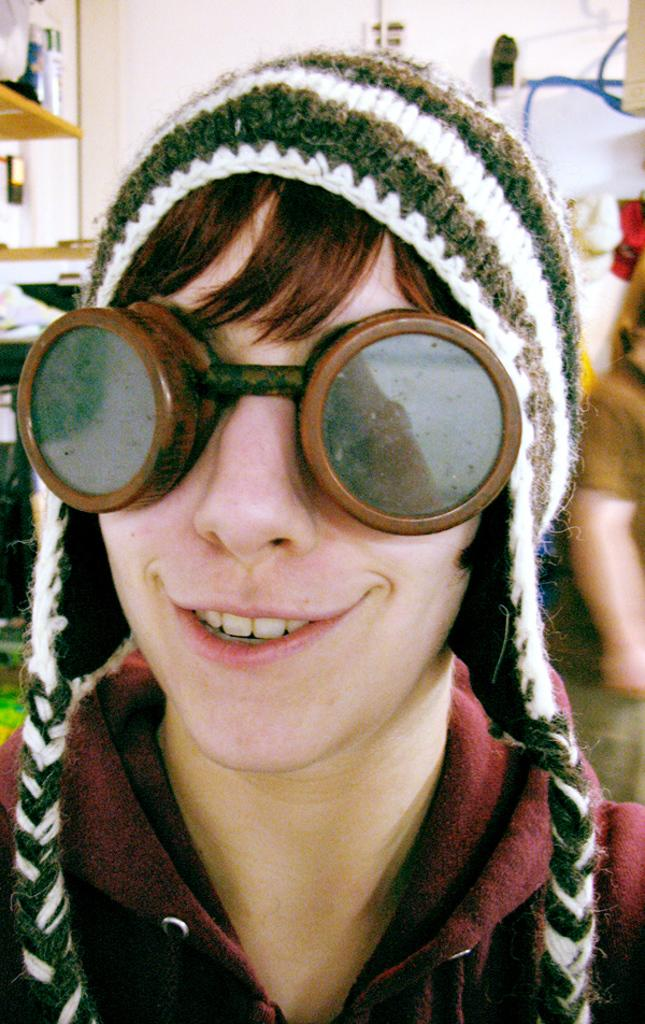Who is taking the picture in the image? There is a person taking the picture in the image. What can be observed about the person's appearance? The person is wearing glasses and a winter cap. What can be seen in the background of the image? There are objects in the background of the image. What type of skin care products are visible in the image? There are no skin care products visible in the image. What type of vacation destination is shown in the image? There is no vacation destination shown in the image; it features a person taking a picture while wearing glasses and a winter cap. 